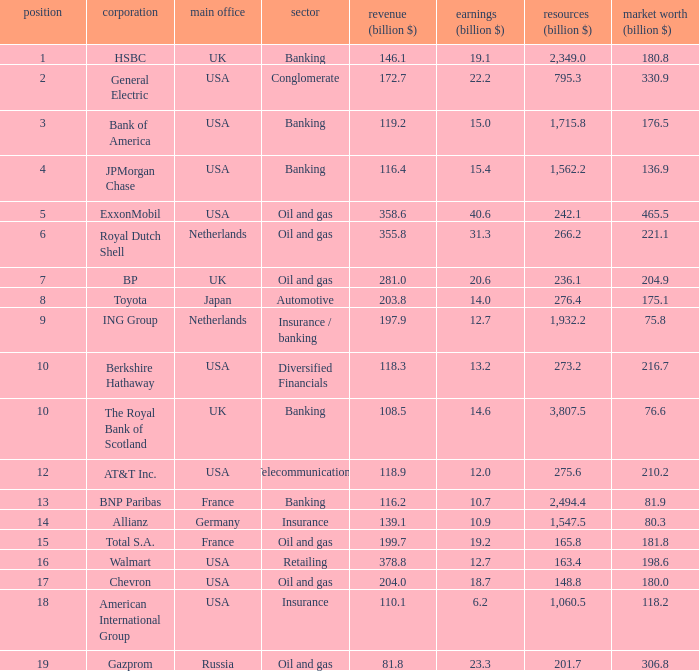What is the billion-dollar market value of a company with 172.7 billion in sales? 330.9. 